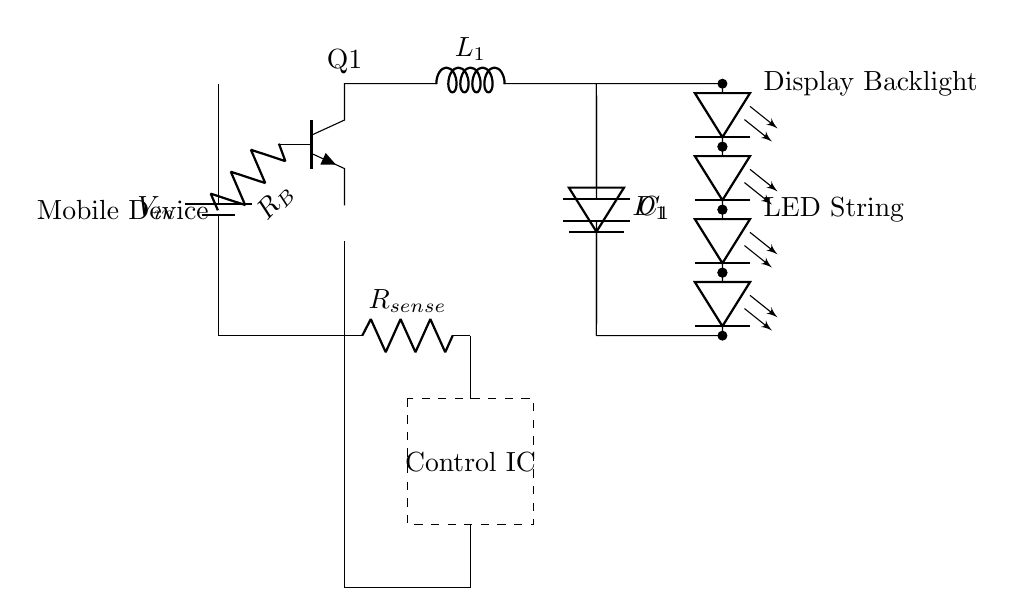What is the input voltage of this circuit? The input voltage, represented as V_in, is the power source for the circuit. It is connected to the battery symbol at the top left of the diagram.
Answer: V_in How many LEDs are in the LED string? The circuit diagram shows a series of four LED components labeled LED1, LED2, LED3, and LED4, connected together.
Answer: 4 What component limits the current in this circuit? The current sense resistor, denoted as R_sense, is used to monitor the current flowing through the circuit. It is placed in series on the output path.
Answer: R_sense What role does the inductor play in the circuit? The inductor, labeled L_1, helps in energy storage and smoothening the output current, especially during the switching operation of the transistor.
Answer: Energy storage What is the function of the control IC in this circuit? The control IC regulates the output current flowing to the LED string, ensuring consistent brightness by adjusting the switching of Q1 based on feedback.
Answer: Regulate current What type of transistor is used in this circuit? The transistor in the circuit is labeled as Q1 and is of the NPn type, which is used for switching applications in low-power circuits.
Answer: NPn What connects the output of the circuit to the LED string? The output of the circuit is connected to the LED string through a direct connection from the output capacitor C_1 to the LEDs.
Answer: Direct connection 